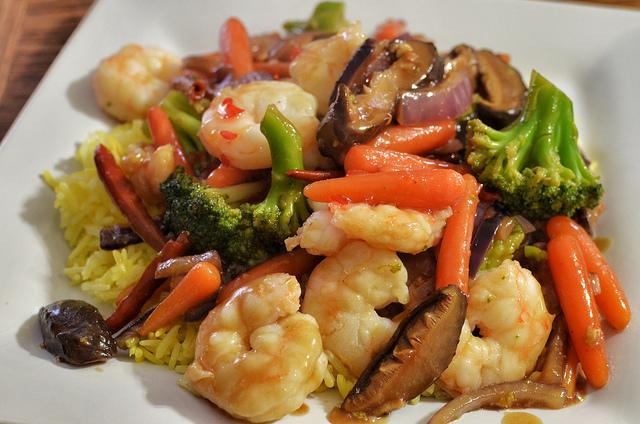Is this made with white rice?
Short answer required. No. Is this meal easy to prepare?
Answer briefly. Yes. What kind of seafood is featured here?
Be succinct. Shrimp. What are the orange things on the plate?
Be succinct. Carrots. Is there any rice on the plate?
Concise answer only. Yes. 